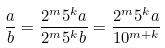Convert formula to latex. <formula><loc_0><loc_0><loc_500><loc_500>\frac { a } { b } = \frac { 2 ^ { m } 5 ^ { k } a } { 2 ^ { m } 5 ^ { k } b } = \frac { 2 ^ { m } 5 ^ { k } a } { 1 0 ^ { m + k } }</formula> 